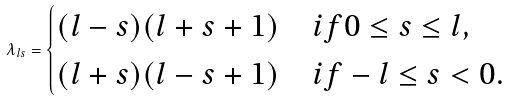Convert formula to latex. <formula><loc_0><loc_0><loc_500><loc_500>\lambda _ { l s } = \begin{cases} ( l - s ) ( l + s + 1 ) & i f 0 \leq s \leq l , \\ ( l + s ) ( l - s + 1 ) & i f - l \leq s < 0 . \end{cases}</formula> 